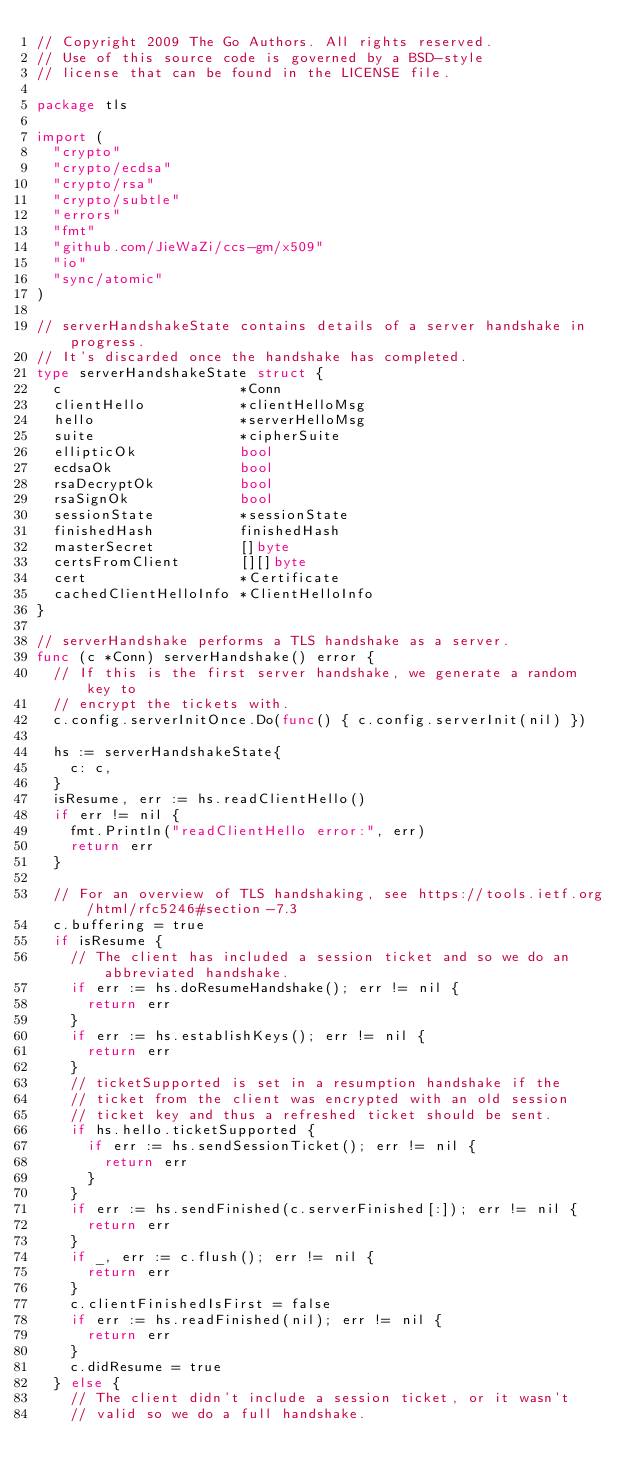Convert code to text. <code><loc_0><loc_0><loc_500><loc_500><_Go_>// Copyright 2009 The Go Authors. All rights reserved.
// Use of this source code is governed by a BSD-style
// license that can be found in the LICENSE file.

package tls

import (
	"crypto"
	"crypto/ecdsa"
	"crypto/rsa"
	"crypto/subtle"
	"errors"
	"fmt"
	"github.com/JieWaZi/ccs-gm/x509"
	"io"
	"sync/atomic"
)

// serverHandshakeState contains details of a server handshake in progress.
// It's discarded once the handshake has completed.
type serverHandshakeState struct {
	c                     *Conn
	clientHello           *clientHelloMsg
	hello                 *serverHelloMsg
	suite                 *cipherSuite
	ellipticOk            bool
	ecdsaOk               bool
	rsaDecryptOk          bool
	rsaSignOk             bool
	sessionState          *sessionState
	finishedHash          finishedHash
	masterSecret          []byte
	certsFromClient       [][]byte
	cert                  *Certificate
	cachedClientHelloInfo *ClientHelloInfo
}

// serverHandshake performs a TLS handshake as a server.
func (c *Conn) serverHandshake() error {
	// If this is the first server handshake, we generate a random key to
	// encrypt the tickets with.
	c.config.serverInitOnce.Do(func() { c.config.serverInit(nil) })

	hs := serverHandshakeState{
		c: c,
	}
	isResume, err := hs.readClientHello()
	if err != nil {
		fmt.Println("readClientHello error:", err)
		return err
	}

	// For an overview of TLS handshaking, see https://tools.ietf.org/html/rfc5246#section-7.3
	c.buffering = true
	if isResume {
		// The client has included a session ticket and so we do an abbreviated handshake.
		if err := hs.doResumeHandshake(); err != nil {
			return err
		}
		if err := hs.establishKeys(); err != nil {
			return err
		}
		// ticketSupported is set in a resumption handshake if the
		// ticket from the client was encrypted with an old session
		// ticket key and thus a refreshed ticket should be sent.
		if hs.hello.ticketSupported {
			if err := hs.sendSessionTicket(); err != nil {
				return err
			}
		}
		if err := hs.sendFinished(c.serverFinished[:]); err != nil {
			return err
		}
		if _, err := c.flush(); err != nil {
			return err
		}
		c.clientFinishedIsFirst = false
		if err := hs.readFinished(nil); err != nil {
			return err
		}
		c.didResume = true
	} else {
		// The client didn't include a session ticket, or it wasn't
		// valid so we do a full handshake.</code> 